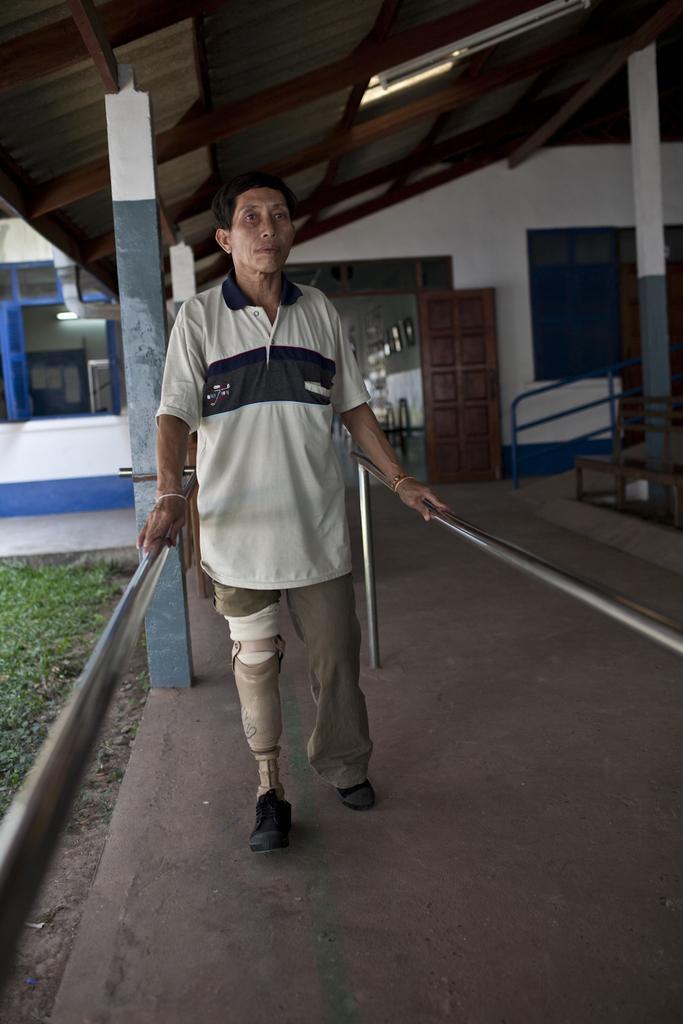What is the person in the image doing? The person is standing on the floor and holding grills on either side. What can be seen in the background of the image? There is a shed, a ramp, doors, walls, windows, and grass in the background of the image. What type of poison is being used to rub the grills in the image? There is no mention of poison or rubbing in the image; the person is simply holding the grills. 